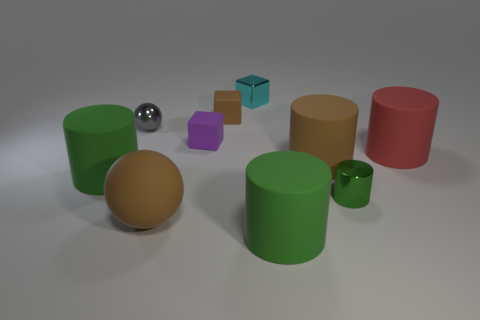How many green things are left of the green matte cylinder that is to the right of the tiny shiny thing behind the gray sphere?
Ensure brevity in your answer.  1. Is the shape of the large green object behind the tiny cylinder the same as  the large red object?
Keep it short and to the point. Yes. There is a matte object behind the small purple thing; is there a tiny shiny object that is on the right side of it?
Offer a very short reply. Yes. What number of small green spheres are there?
Your answer should be compact. 0. What color is the tiny metal thing that is in front of the tiny shiny block and left of the large brown cylinder?
Offer a very short reply. Gray. There is a brown rubber thing that is the same shape as the tiny cyan object; what is its size?
Ensure brevity in your answer.  Small. What number of other objects are the same size as the cyan thing?
Give a very brief answer. 4. What is the material of the large brown ball?
Offer a very short reply. Rubber. There is a small shiny cylinder; are there any tiny shiny objects behind it?
Your response must be concise. Yes. What is the size of the red cylinder that is the same material as the small purple thing?
Provide a succinct answer. Large. 